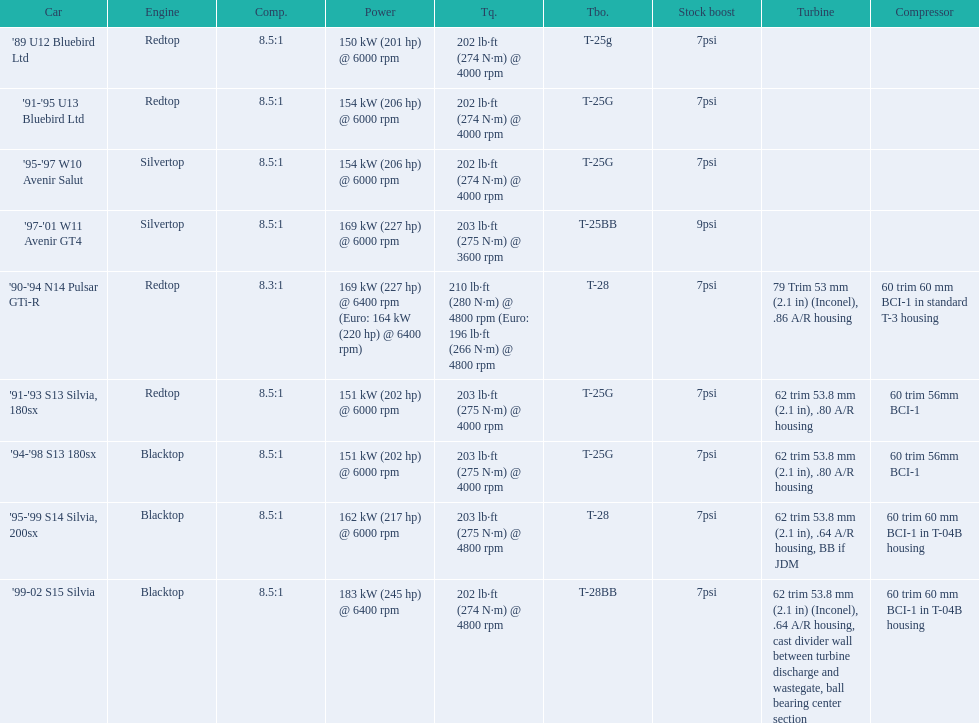What are the psi's? 7psi, 7psi, 7psi, 9psi, 7psi, 7psi, 7psi, 7psi, 7psi. What are the number(s) greater than 7? 9psi. Which car has that number? '97-'01 W11 Avenir GT4. 